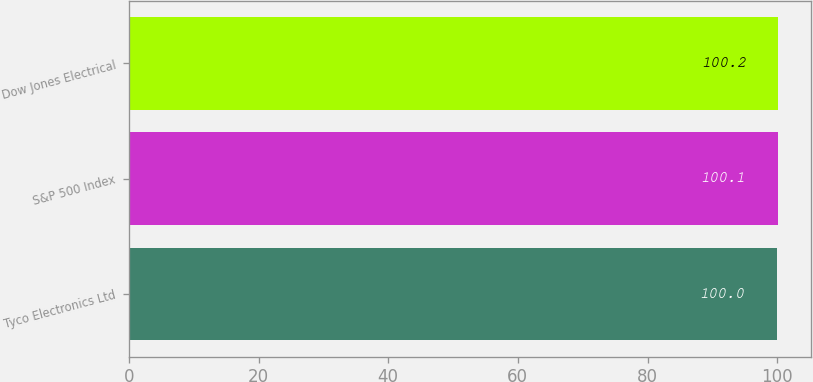Convert chart to OTSL. <chart><loc_0><loc_0><loc_500><loc_500><bar_chart><fcel>Tyco Electronics Ltd<fcel>S&P 500 Index<fcel>Dow Jones Electrical<nl><fcel>100<fcel>100.1<fcel>100.2<nl></chart> 